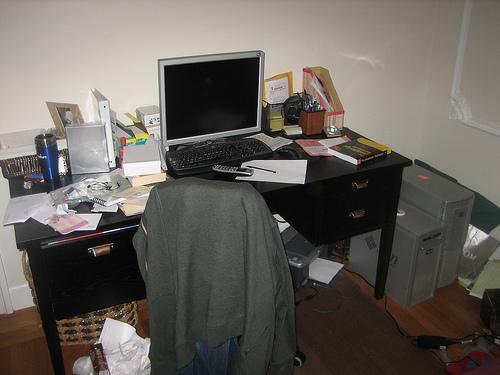How many computer towers are there?
Give a very brief answer. 2. 